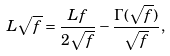Convert formula to latex. <formula><loc_0><loc_0><loc_500><loc_500>L \sqrt { f } = \frac { L f } { 2 \sqrt { f } } - \frac { \Gamma ( \sqrt { f } ) } { \sqrt { f } } ,</formula> 